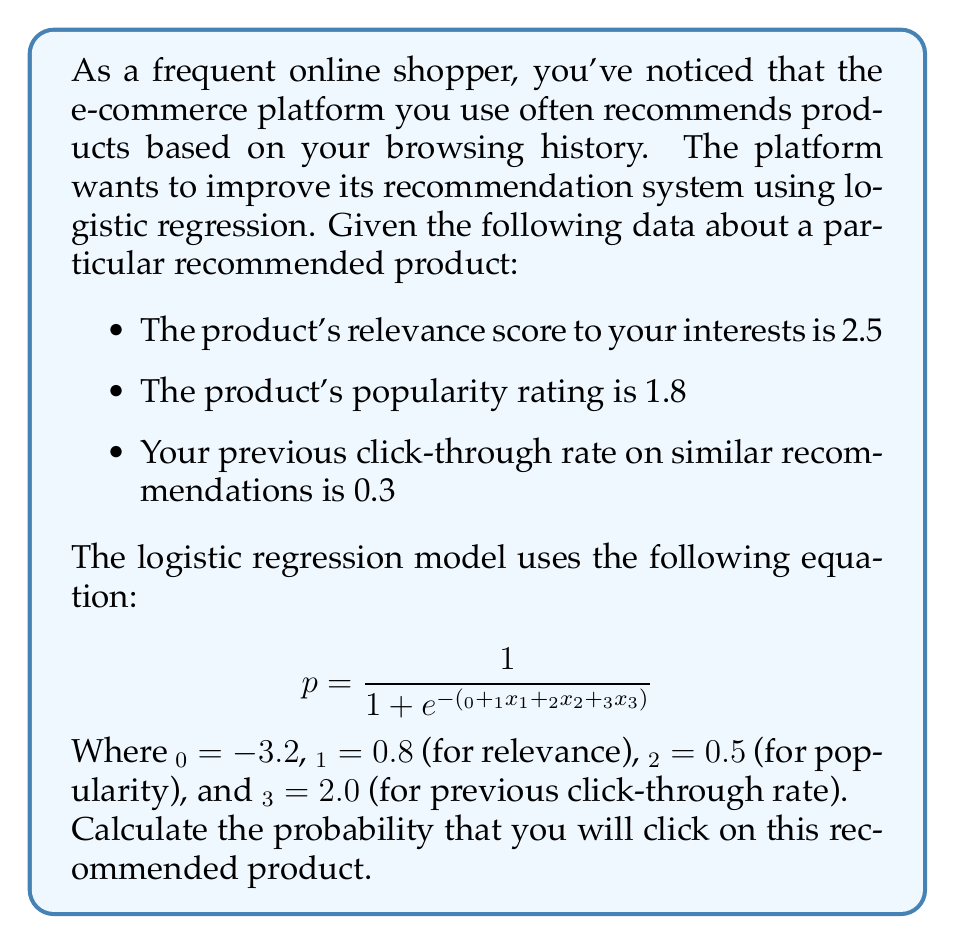Can you solve this math problem? To solve this problem, we need to follow these steps:

1. Identify the values for each variable:
   $x_1 = 2.5$ (relevance score)
   $x_2 = 1.8$ (popularity rating)
   $x_3 = 0.3$ (previous click-through rate)

2. Substitute these values and the given β coefficients into the equation:

   $$ p = \frac{1}{1 + e^{-(-3.2 + 0.8(2.5) + 0.5(1.8) + 2.0(0.3))}} $$

3. Calculate the expression inside the exponential:
   $-3.2 + 0.8(2.5) + 0.5(1.8) + 2.0(0.3)$
   $= -3.2 + 2.0 + 0.9 + 0.6$
   $= 0.3$

4. Now our equation looks like this:

   $$ p = \frac{1}{1 + e^{-0.3}} $$

5. Calculate $e^{-0.3}$:
   $e^{-0.3} ≈ 0.7408$ (rounded to 4 decimal places)

6. Substitute this value:

   $$ p = \frac{1}{1 + 0.7408} = \frac{1}{1.7408} $$

7. Perform the final division:
   $p ≈ 0.5744$ (rounded to 4 decimal places)

8. Convert to a percentage:
   0.5744 * 100 = 57.44%

Therefore, the probability that you will click on this recommended product is approximately 57.44%.
Answer: 57.44% 